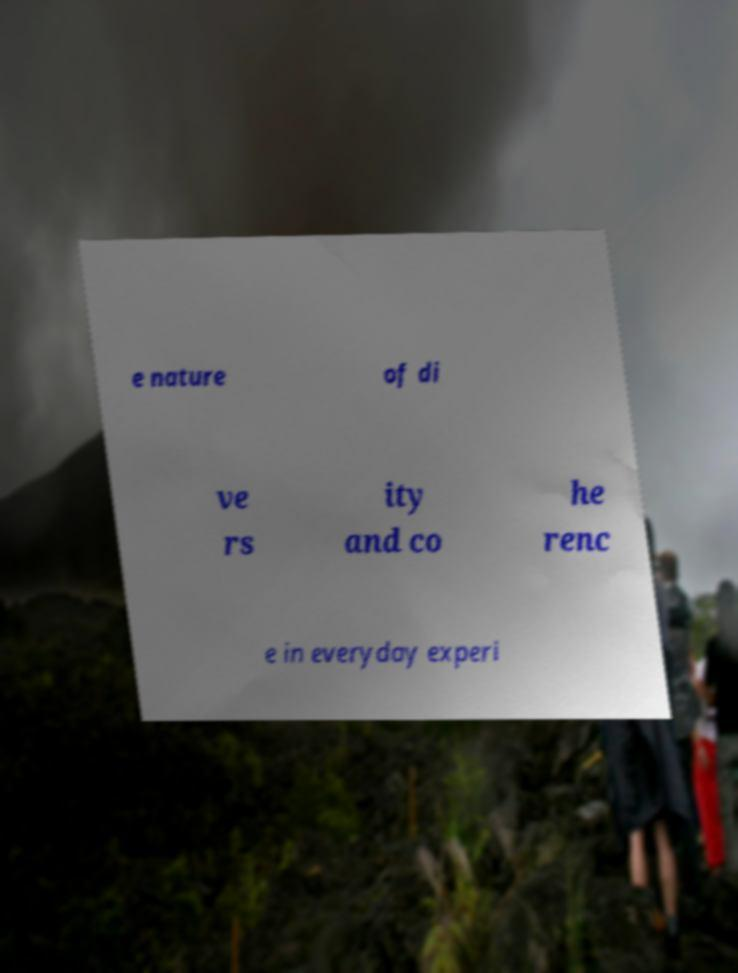For documentation purposes, I need the text within this image transcribed. Could you provide that? e nature of di ve rs ity and co he renc e in everyday experi 